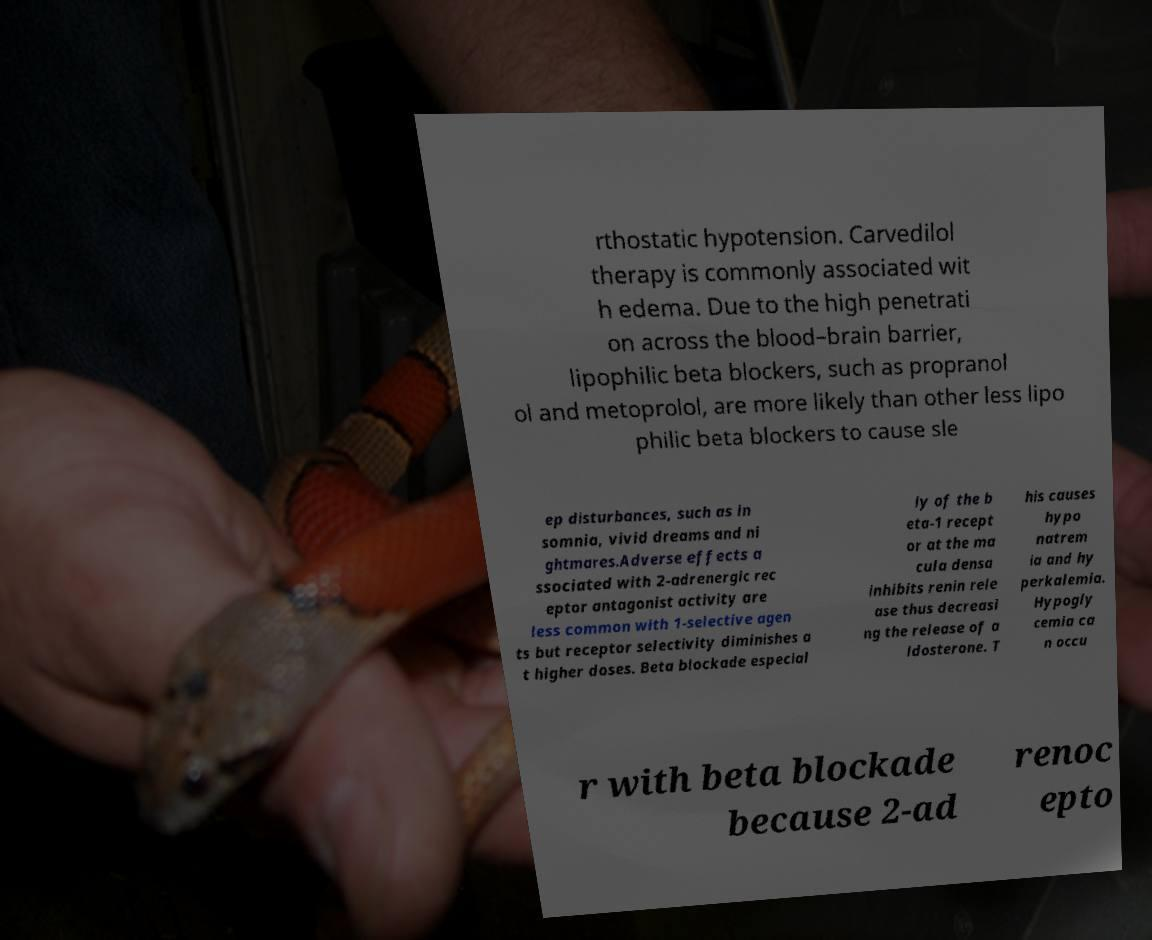There's text embedded in this image that I need extracted. Can you transcribe it verbatim? rthostatic hypotension. Carvedilol therapy is commonly associated wit h edema. Due to the high penetrati on across the blood–brain barrier, lipophilic beta blockers, such as propranol ol and metoprolol, are more likely than other less lipo philic beta blockers to cause sle ep disturbances, such as in somnia, vivid dreams and ni ghtmares.Adverse effects a ssociated with 2-adrenergic rec eptor antagonist activity are less common with 1-selective agen ts but receptor selectivity diminishes a t higher doses. Beta blockade especial ly of the b eta-1 recept or at the ma cula densa inhibits renin rele ase thus decreasi ng the release of a ldosterone. T his causes hypo natrem ia and hy perkalemia. Hypogly cemia ca n occu r with beta blockade because 2-ad renoc epto 